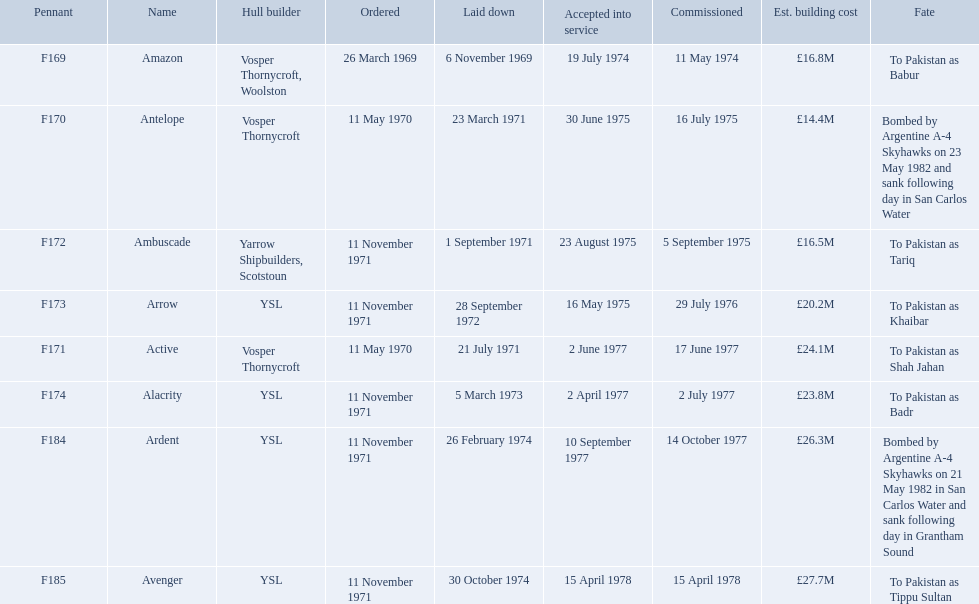Which type 21 frigate ships were to be built by ysl in the 1970s? Arrow, Alacrity, Ardent, Avenger. Of these ships, which one had the highest estimated building cost? Avenger. 